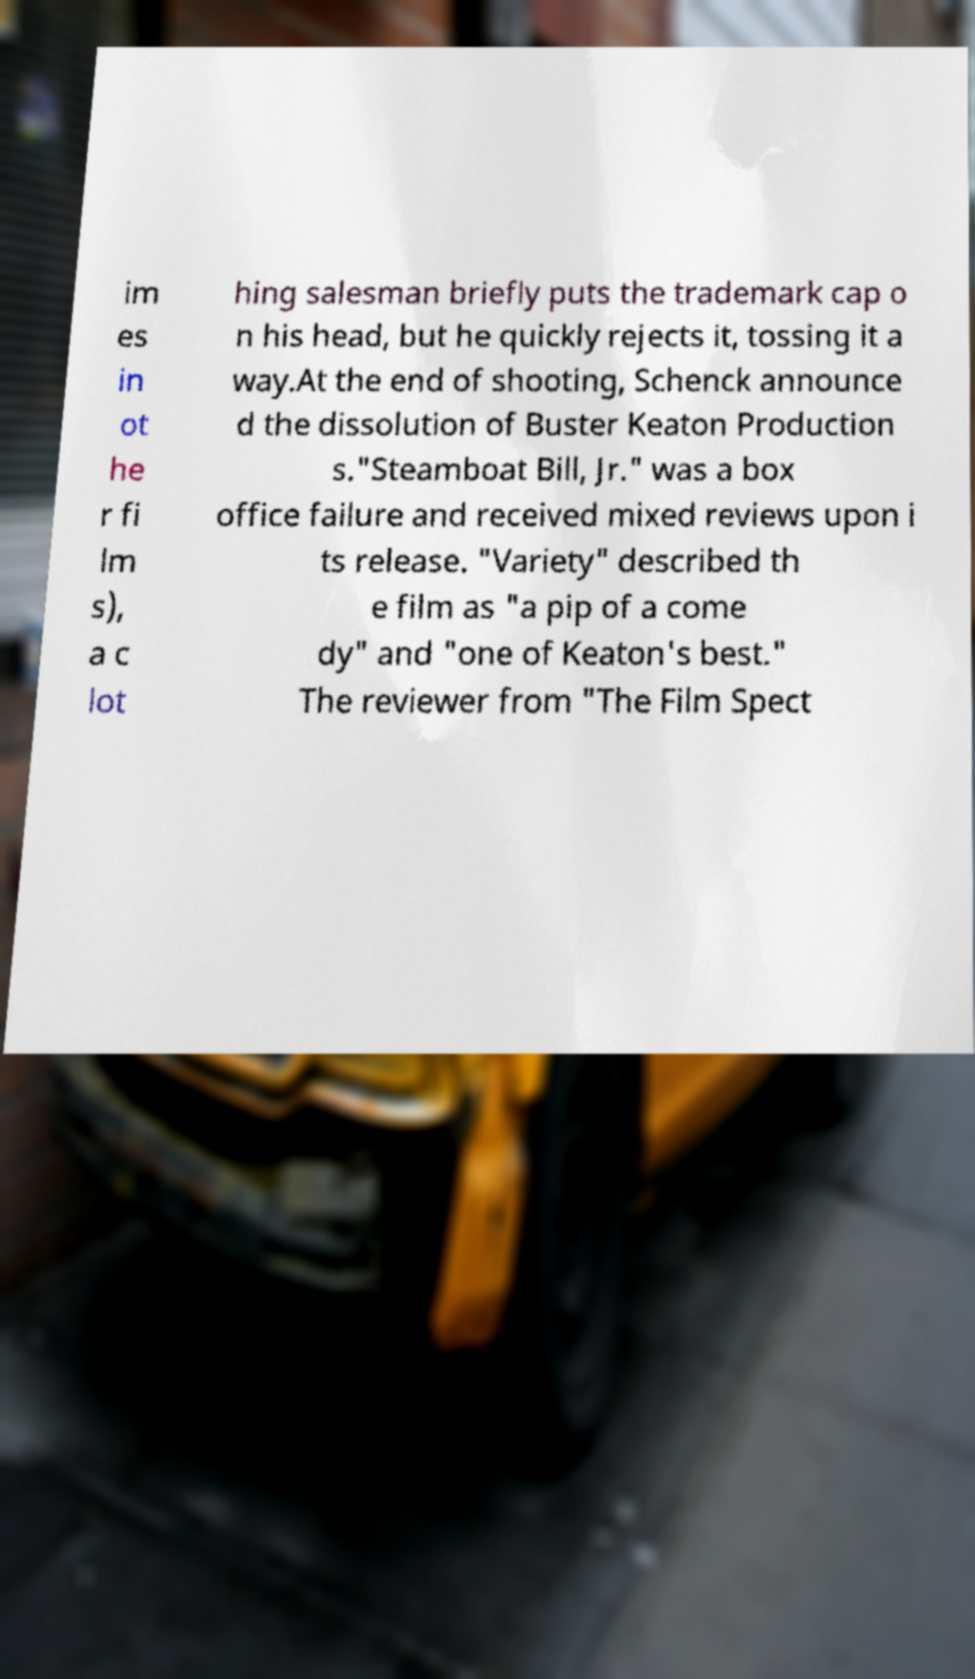Could you assist in decoding the text presented in this image and type it out clearly? im es in ot he r fi lm s), a c lot hing salesman briefly puts the trademark cap o n his head, but he quickly rejects it, tossing it a way.At the end of shooting, Schenck announce d the dissolution of Buster Keaton Production s."Steamboat Bill, Jr." was a box office failure and received mixed reviews upon i ts release. "Variety" described th e film as "a pip of a come dy" and "one of Keaton's best." The reviewer from "The Film Spect 